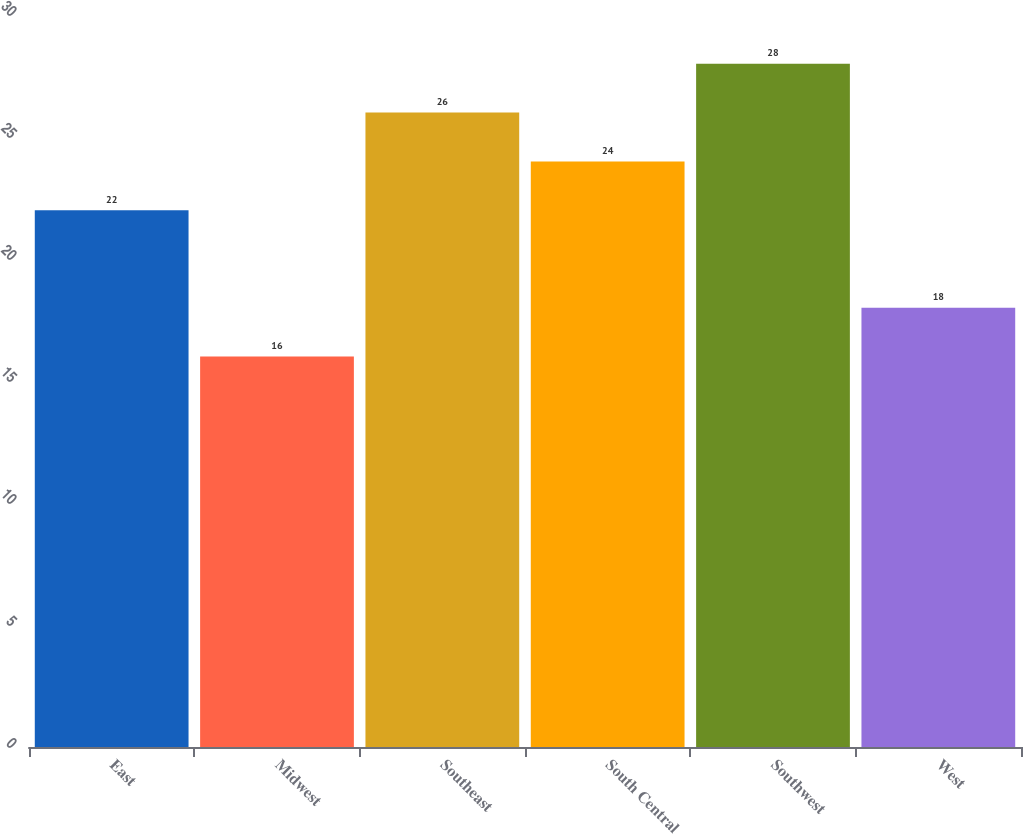Convert chart. <chart><loc_0><loc_0><loc_500><loc_500><bar_chart><fcel>East<fcel>Midwest<fcel>Southeast<fcel>South Central<fcel>Southwest<fcel>West<nl><fcel>22<fcel>16<fcel>26<fcel>24<fcel>28<fcel>18<nl></chart> 